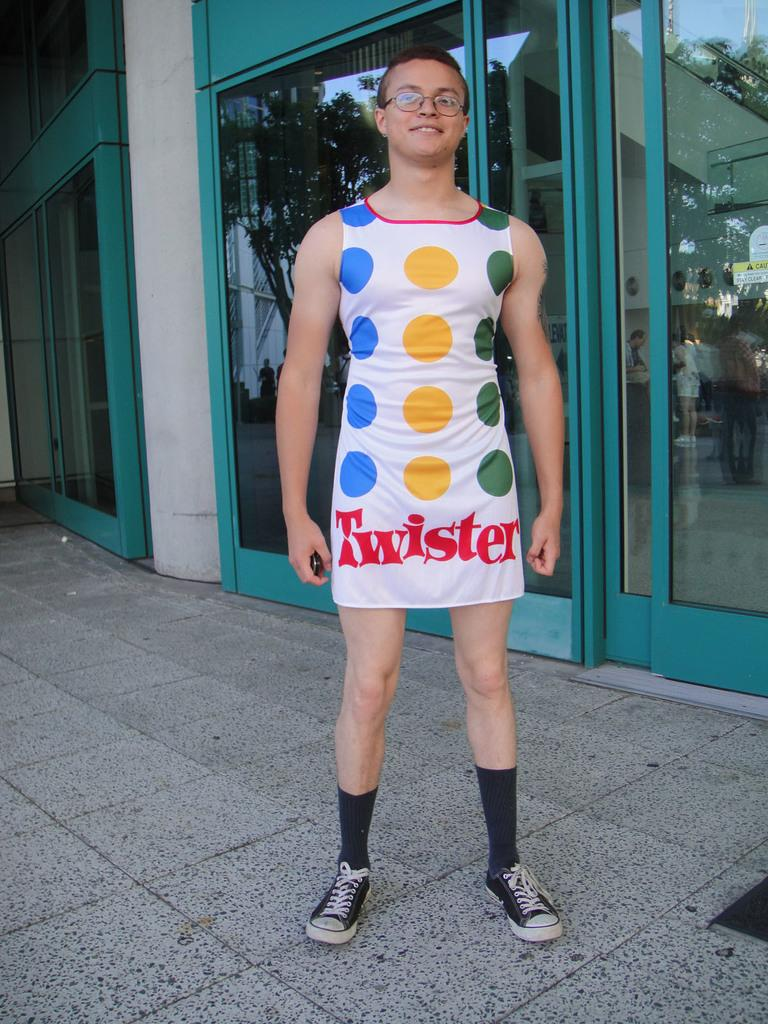<image>
Relay a brief, clear account of the picture shown. A person is wearing a Twister board as a dress and smiling proudly. 